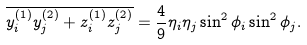<formula> <loc_0><loc_0><loc_500><loc_500>\overline { y _ { i } ^ { ( 1 ) } y _ { j } ^ { ( 2 ) } + z _ { i } ^ { ( 1 ) } z _ { j } ^ { ( 2 ) } } = \frac { 4 } { 9 } \eta _ { i } \eta _ { j } \sin ^ { 2 } \phi _ { i } \sin ^ { 2 } \phi _ { j } .</formula> 